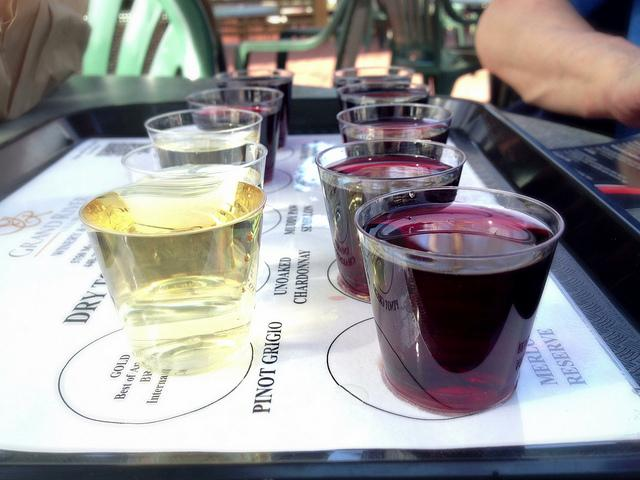What does the printing on the mat indicate?

Choices:
A) wine varieties
B) names
C) people locations
D) destination wine varieties 